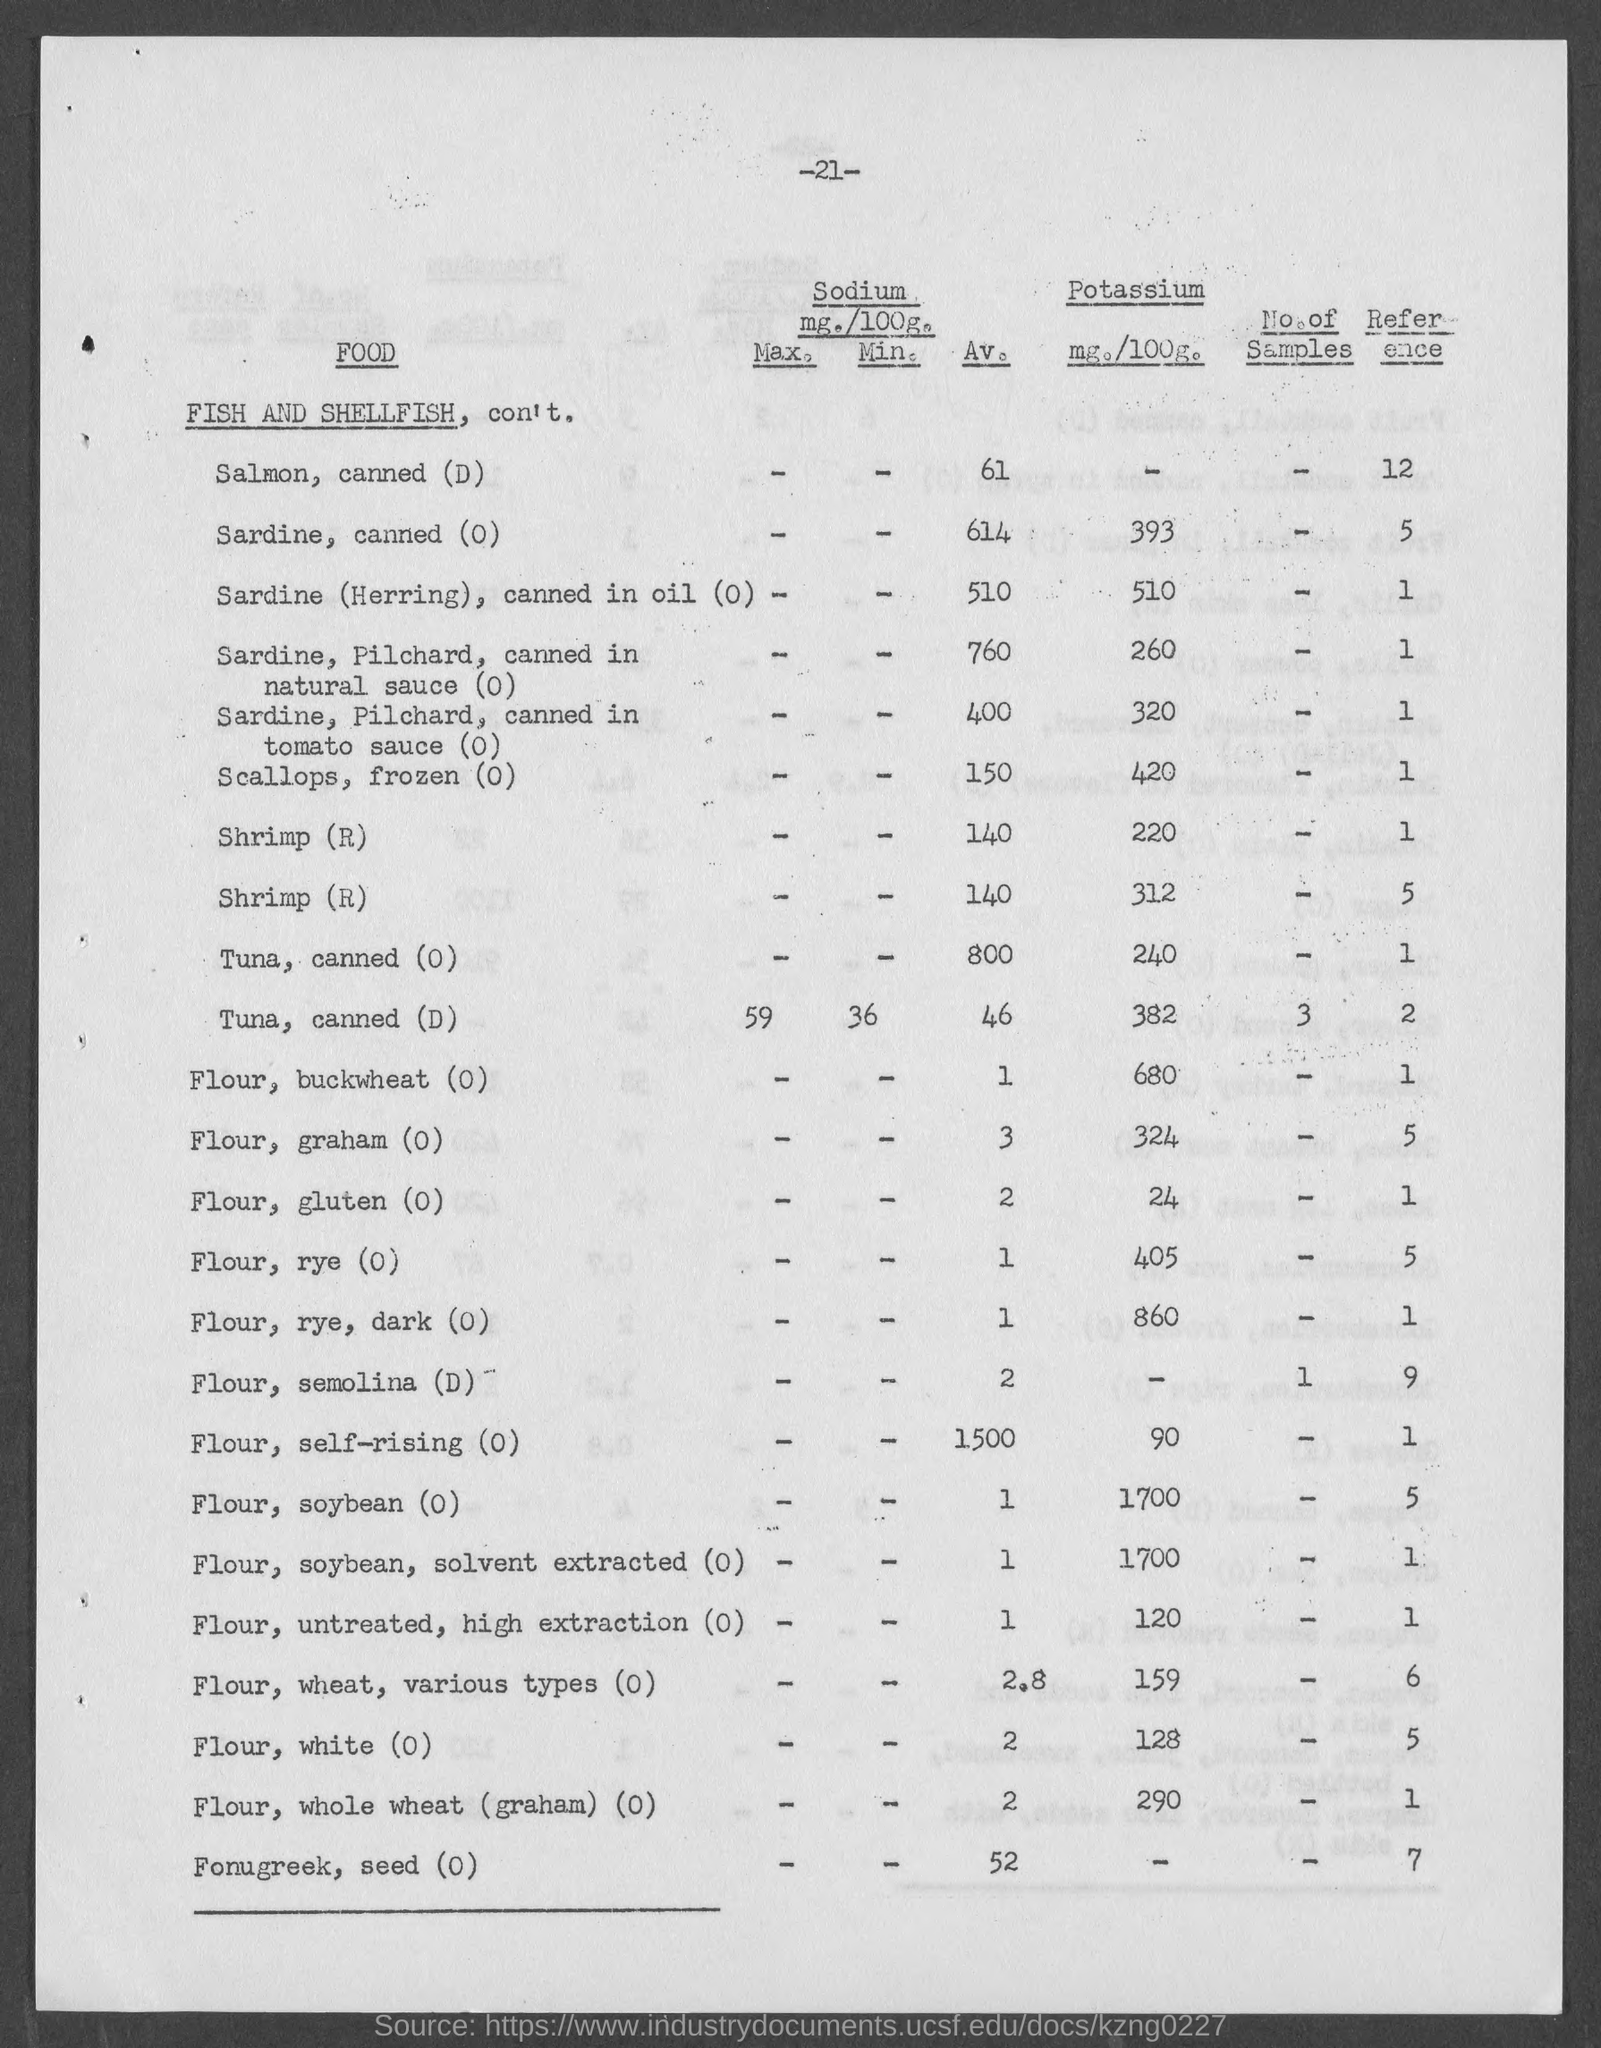Mention a couple of crucial points in this snapshot. The average amount of sodium in a serving of canned tuna, option D, is 46 milligrams. The average sodium content for canned tuna is not available for values less than 800 mg. The average amount of sodium in canned sardines (herring) in oil is 510 milligrams per serving. The average amount of sodium in frozen scallops is 150 milligrams per serving. The average sodium content for canned salmon, labeled as "D" is 61 mg per 100 grams. 